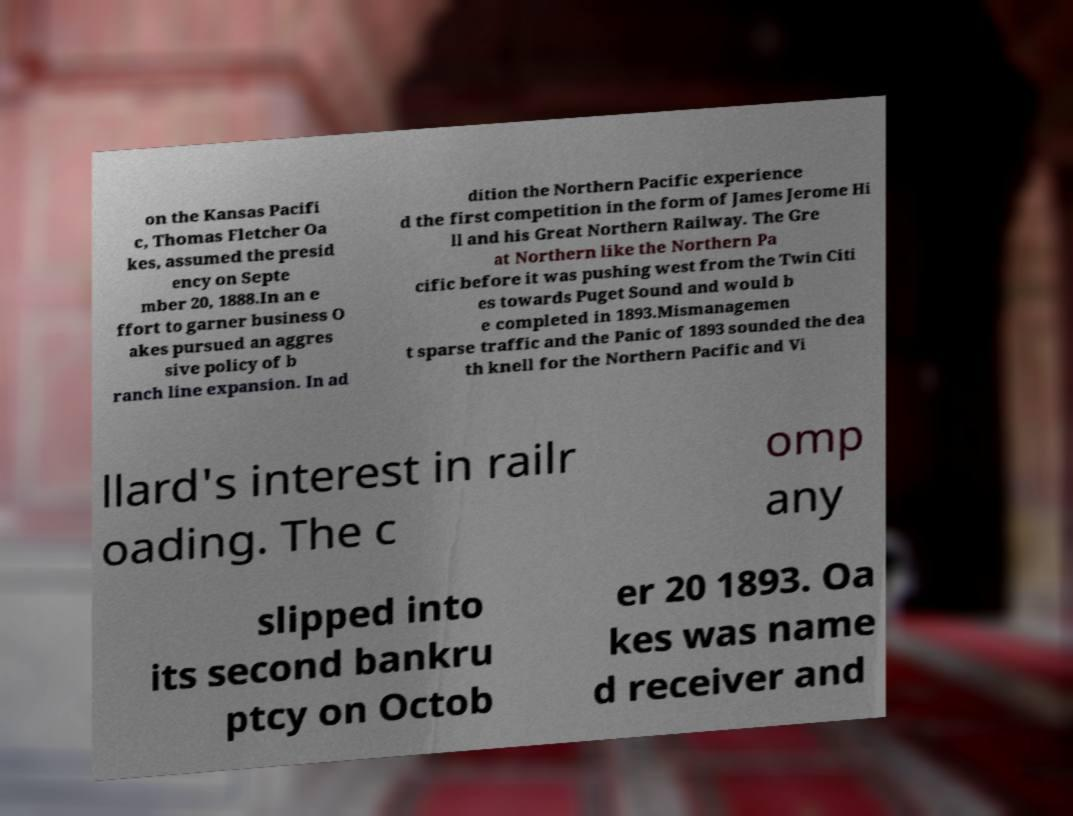Could you extract and type out the text from this image? on the Kansas Pacifi c, Thomas Fletcher Oa kes, assumed the presid ency on Septe mber 20, 1888.In an e ffort to garner business O akes pursued an aggres sive policy of b ranch line expansion. In ad dition the Northern Pacific experience d the first competition in the form of James Jerome Hi ll and his Great Northern Railway. The Gre at Northern like the Northern Pa cific before it was pushing west from the Twin Citi es towards Puget Sound and would b e completed in 1893.Mismanagemen t sparse traffic and the Panic of 1893 sounded the dea th knell for the Northern Pacific and Vi llard's interest in railr oading. The c omp any slipped into its second bankru ptcy on Octob er 20 1893. Oa kes was name d receiver and 